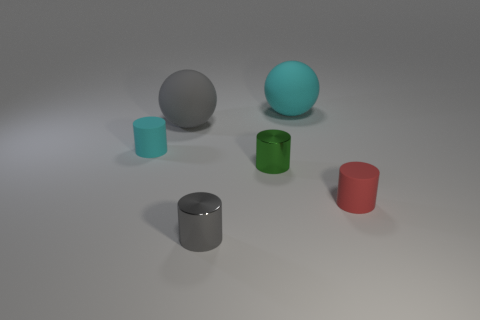Subtract all purple cylinders. Subtract all green blocks. How many cylinders are left? 4 Subtract all yellow balls. How many red cylinders are left? 1 Add 2 reds. How many things exist? 0 Subtract all big things. Subtract all red matte cylinders. How many objects are left? 3 Add 4 rubber spheres. How many rubber spheres are left? 6 Add 6 small cylinders. How many small cylinders exist? 10 Add 2 large cyan rubber cubes. How many objects exist? 8 Subtract all green cylinders. How many cylinders are left? 3 Subtract all small gray cylinders. How many cylinders are left? 3 Subtract 0 purple spheres. How many objects are left? 6 